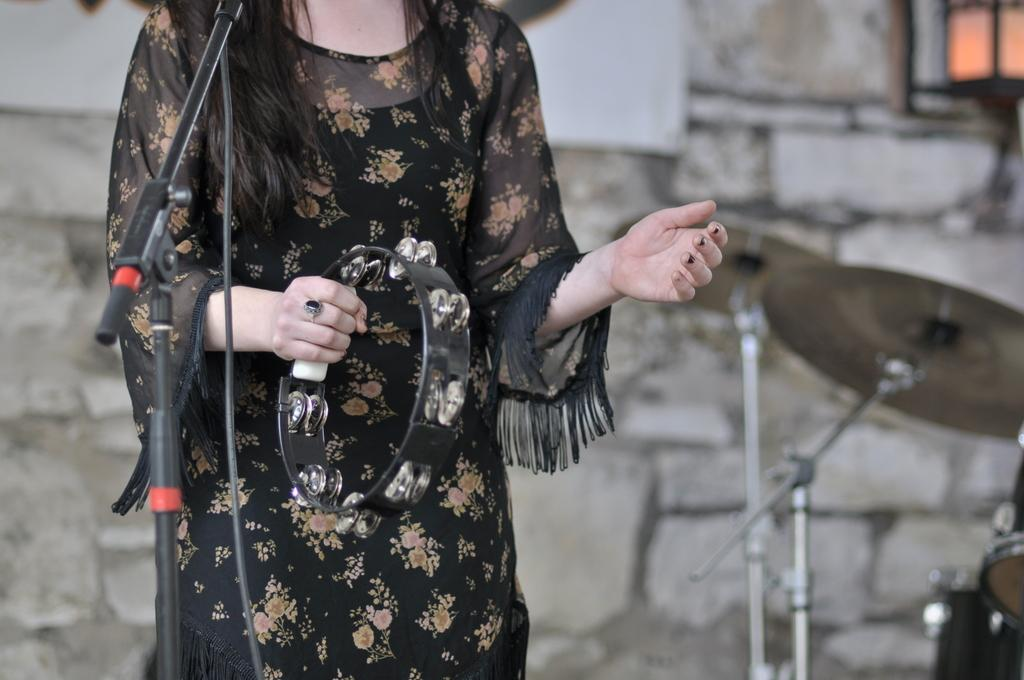What is the woman holding in the image? The woman is holding a musical instrument. What can be seen near the woman in the image? There is a mic stand in the image. What else is present in the image related to music? There is a cable and other musical instruments in the image. How would you describe the background of the image? The background of the image is blurry, and there is a wall visible. What type of silk fabric is draped over the ball in the alley in the image? There is no silk fabric, ball, or alley present in the image. 